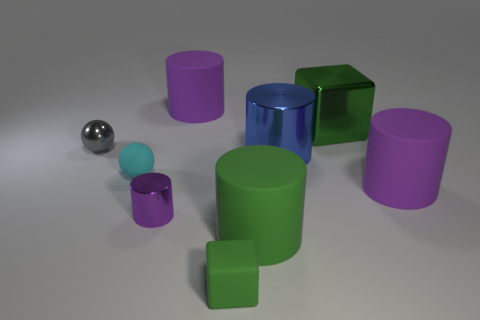Subtract all purple cylinders. How many were subtracted if there are1purple cylinders left? 2 Subtract all brown spheres. How many purple cylinders are left? 3 Subtract all blue cylinders. How many cylinders are left? 4 Subtract all tiny purple metallic cylinders. How many cylinders are left? 4 Subtract all brown cylinders. Subtract all red cubes. How many cylinders are left? 5 Add 1 small green cubes. How many objects exist? 10 Subtract all balls. How many objects are left? 7 Add 2 tiny metal spheres. How many tiny metal spheres are left? 3 Add 5 large blue cylinders. How many large blue cylinders exist? 6 Subtract 0 brown cylinders. How many objects are left? 9 